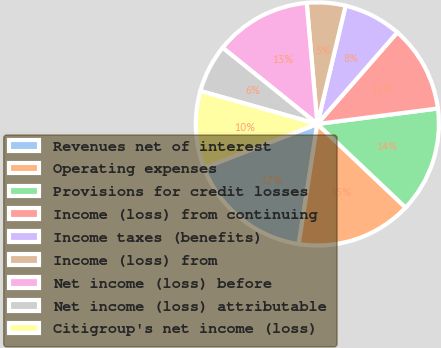<chart> <loc_0><loc_0><loc_500><loc_500><pie_chart><fcel>Revenues net of interest<fcel>Operating expenses<fcel>Provisions for credit losses<fcel>Income (loss) from continuing<fcel>Income taxes (benefits)<fcel>Income (loss) from<fcel>Net income (loss) before<fcel>Net income (loss) attributable<fcel>Citigroup's net income (loss)<nl><fcel>16.67%<fcel>15.38%<fcel>14.1%<fcel>11.54%<fcel>7.69%<fcel>5.13%<fcel>12.82%<fcel>6.41%<fcel>10.26%<nl></chart> 